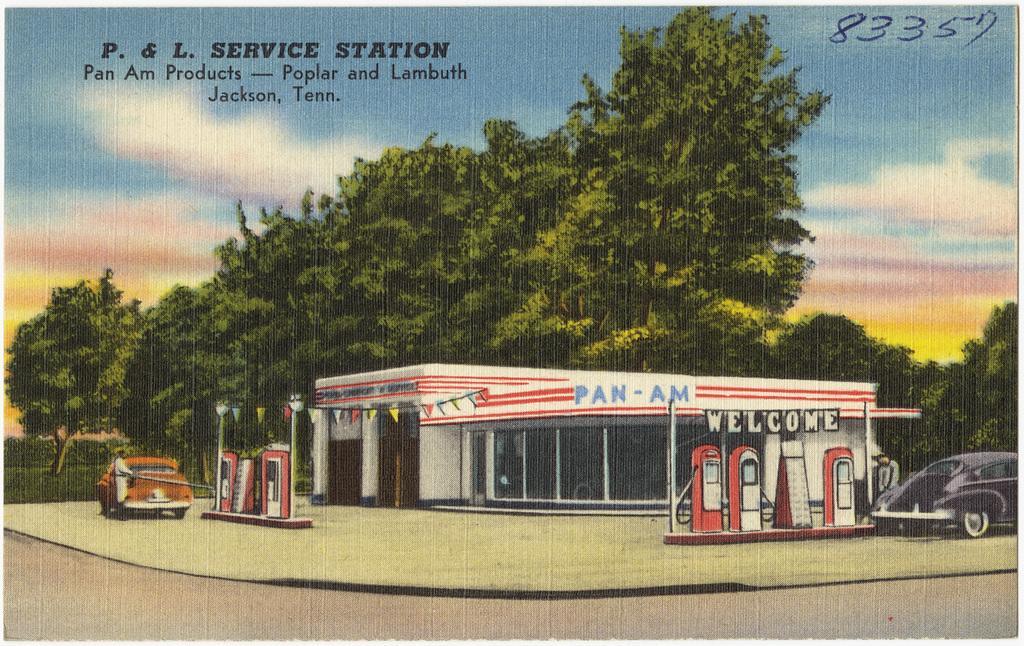Could you give a brief overview of what you see in this image? This image is a depiction. In this image we can see a building, flags, booths and also the vehicles. We can also see the road, path, people, trees and also the sky with the clouds. We can also see the text and also numbers at the top. 